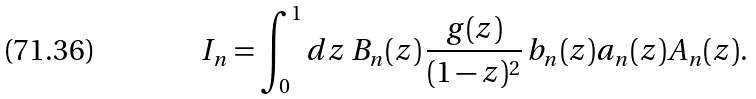Convert formula to latex. <formula><loc_0><loc_0><loc_500><loc_500>I _ { n } = \int _ { 0 } ^ { 1 } d z \, B _ { n } ( z ) \, \frac { g ( z ) } { ( 1 - z ) ^ { 2 } } \, b _ { n } ( z ) a _ { n } ( z ) A _ { n } ( z ) .</formula> 